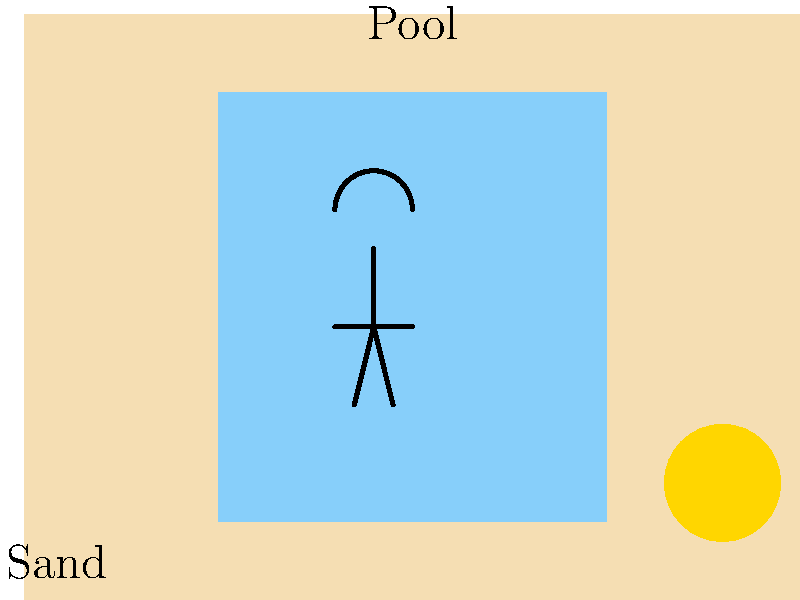A sunbather at a pool in Seychelles notices that the sand around the pool feels much hotter than the pool water, despite both being exposed to the same sunlight. If the sand absorbs 70% of the incident solar radiation and has a specific heat capacity of 830 J/(kg·K), while the water absorbs 30% of the incident solar radiation and has a specific heat capacity of 4186 J/(kg·K), how much more temperature change would 1 kg of sand experience compared to 1 kg of water after 1 hour of exposure to 1000 W/m² of solar radiation? Assume both substances have the same surface area exposed to sunlight. Let's approach this step-by-step:

1) First, calculate the energy absorbed by each substance:
   Energy = Intensity × Time × Absorption rate
   For sand: $E_s = 1000 \text{ W/m²} \times 3600 \text{ s} \times 0.70 = 2,520,000 \text{ J/m²}$
   For water: $E_w = 1000 \text{ W/m²} \times 3600 \text{ s} \times 0.30 = 1,080,000 \text{ J/m²}$

2) The temperature change is given by: $\Delta T = \frac{E}{m \times c}$
   Where $E$ is energy absorbed, $m$ is mass, and $c$ is specific heat capacity.

3) For 1 kg of sand:
   $\Delta T_s = \frac{2,520,000 \text{ J/m²}}{1 \text{ kg} \times 830 \text{ J/(kg·K)}} = 3036.14 \text{ K/m²}$

4) For 1 kg of water:
   $\Delta T_w = \frac{1,080,000 \text{ J/m²}}{1 \text{ kg} \times 4186 \text{ J/(kg·K)}} = 258.00 \text{ K/m²}$

5) The difference in temperature change:
   $\Delta T_s - \Delta T_w = 3036.14 \text{ K/m²} - 258.00 \text{ K/m²} = 2778.14 \text{ K/m²}$

Therefore, 1 kg of sand would experience 2778.14 K/m² more temperature change than 1 kg of water.
Answer: 2778.14 K/m² 